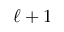Convert formula to latex. <formula><loc_0><loc_0><loc_500><loc_500>\ell + 1</formula> 